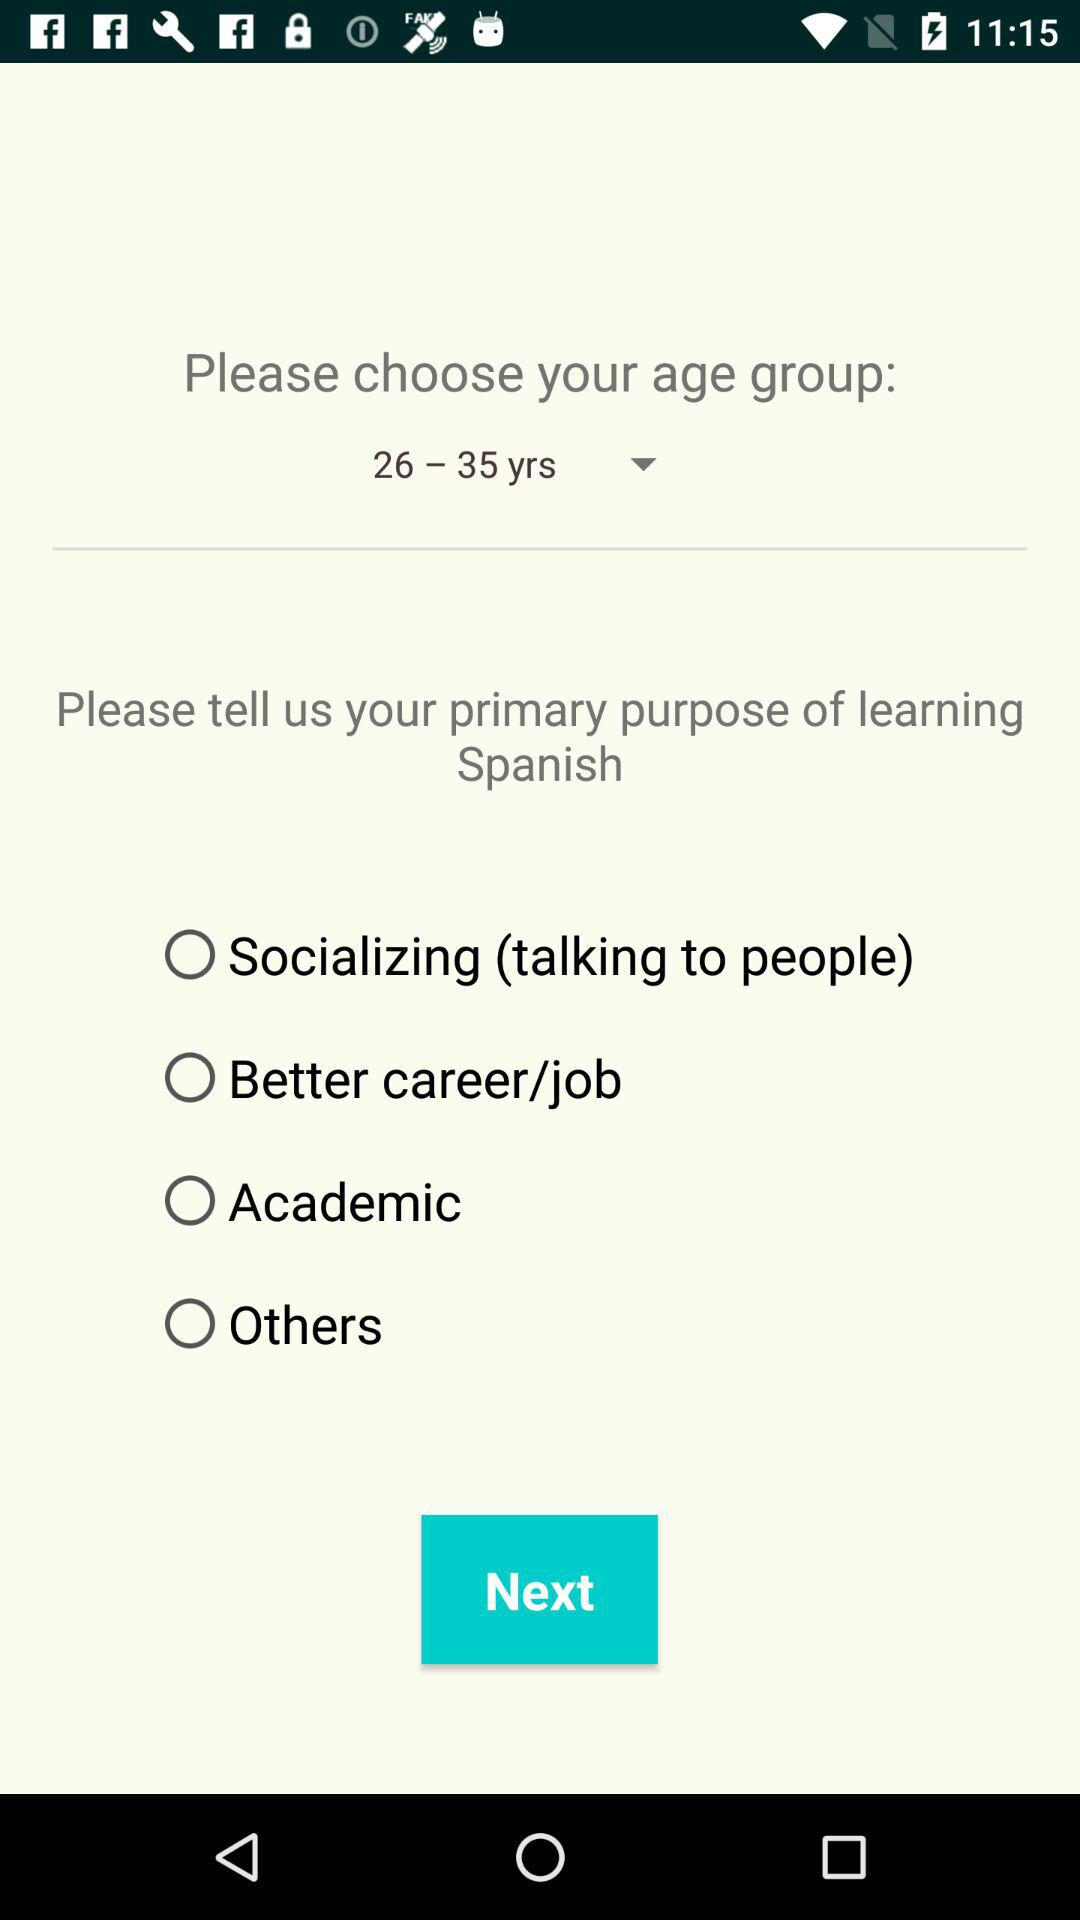How many options are there for primary purpose of learning Spanish?
Answer the question using a single word or phrase. 4 